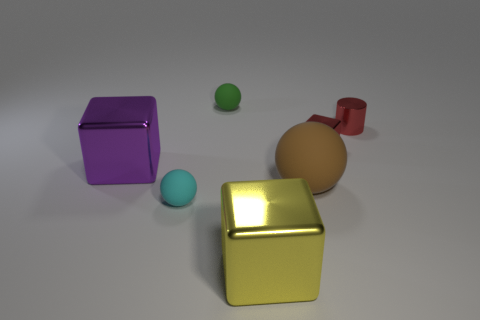The shiny cube that is the same size as the red cylinder is what color?
Offer a terse response. Red. There is a large object that is on the right side of the big yellow shiny block on the right side of the tiny rubber sphere behind the small red metal cylinder; what is its material?
Give a very brief answer. Rubber. Do the tiny cylinder and the small metal thing on the left side of the red cylinder have the same color?
Give a very brief answer. Yes. How many things are either tiny red shiny things that are to the left of the shiny cylinder or metallic objects that are to the left of the tiny red metal cylinder?
Keep it short and to the point. 3. There is a small matte object that is to the left of the ball behind the big brown ball; what is its shape?
Provide a succinct answer. Sphere. Is there a large purple thing that has the same material as the tiny cube?
Your answer should be compact. Yes. What color is the tiny object that is the same shape as the large purple thing?
Ensure brevity in your answer.  Red. Are there fewer tiny metallic cylinders that are on the left side of the large purple shiny cube than tiny cyan matte things that are behind the tiny red cylinder?
Provide a succinct answer. No. Is the number of balls that are in front of the big yellow thing less than the number of large cubes?
Make the answer very short. Yes. What is the material of the big thing in front of the large rubber sphere?
Your answer should be very brief. Metal. 